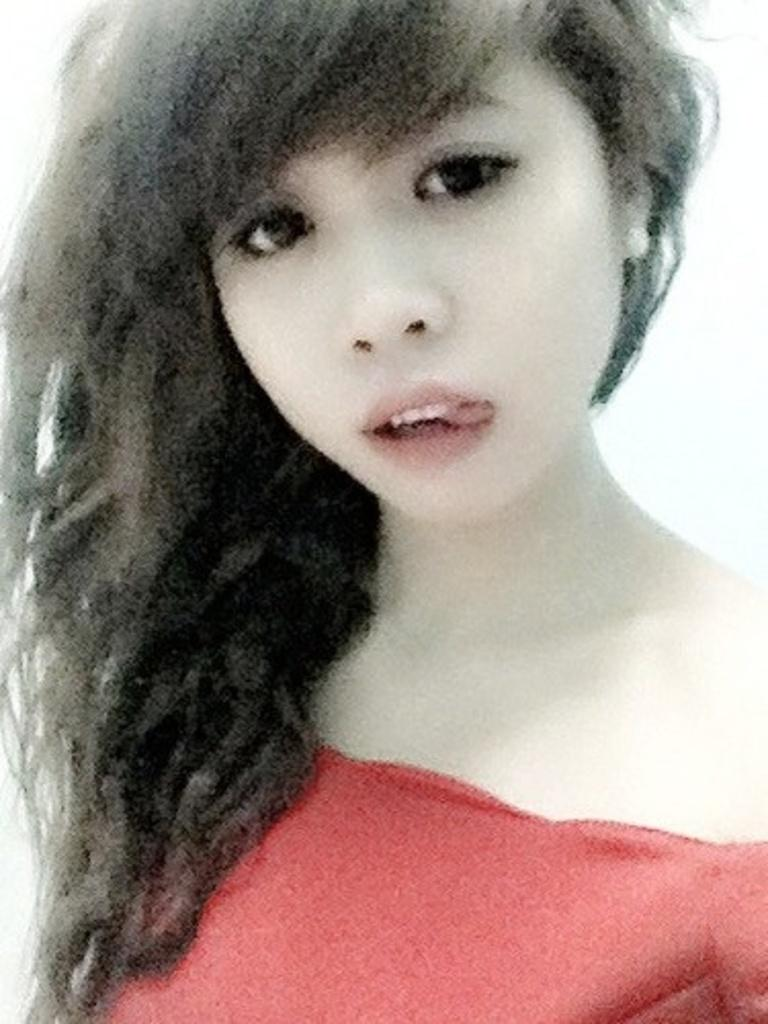What is the main subject of the image? The main subject of the image is a girl. What is the girl wearing in the image? The girl is wearing a red dress. What type of leather material is the girl holding in the image? There is no leather material present in the image. What type of quartz crystal can be seen in the girl's hand in the image? There is no quartz crystal present in the image. Is the girl playing basketball in the image? There is no basketball or indication of basketball playing in the image. 